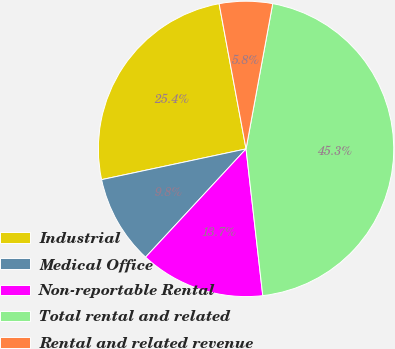<chart> <loc_0><loc_0><loc_500><loc_500><pie_chart><fcel>Industrial<fcel>Medical Office<fcel>Non-reportable Rental<fcel>Total rental and related<fcel>Rental and related revenue<nl><fcel>25.42%<fcel>9.76%<fcel>13.71%<fcel>45.31%<fcel>5.81%<nl></chart> 